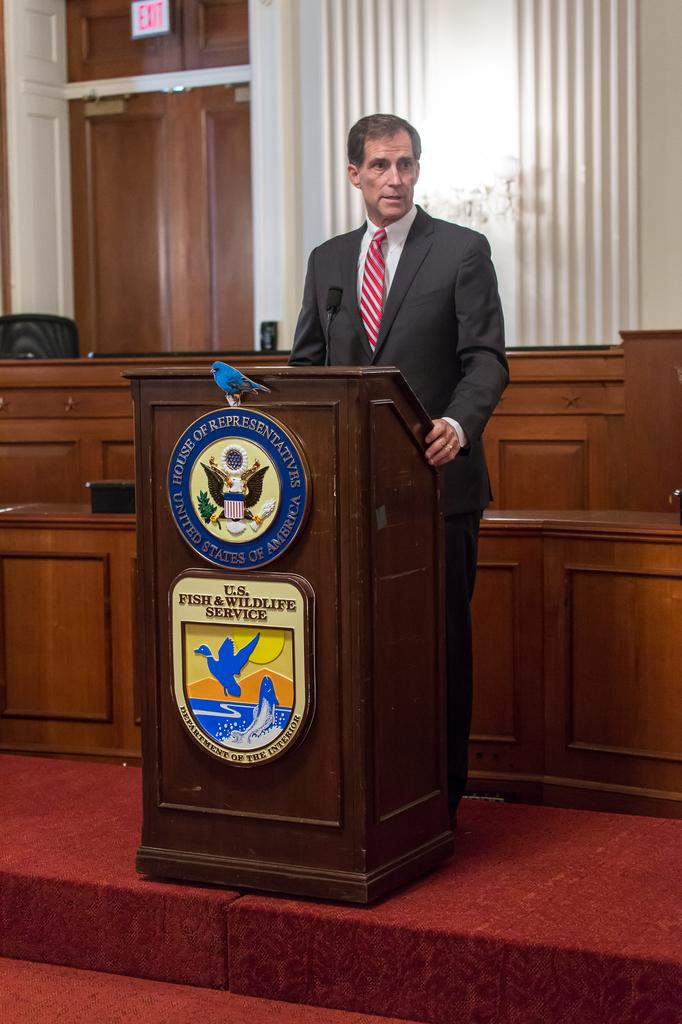What is the person in the image doing? The person is standing in the image. What is the person wearing? The person is wearing a suit. What object is in front of the person? There is a microphone in front of the person. What is the wooden object in front of the person? There is a wooden stand in front of the person. What can be seen in the background of the image? There is a door in the background of the image. What is near the door in the image? There is an exit sign board near the door. Are there any dinosaurs visible in the image? No, there are no dinosaurs present in the image. What type of coast can be seen in the image? There is no coast visible in the image. 